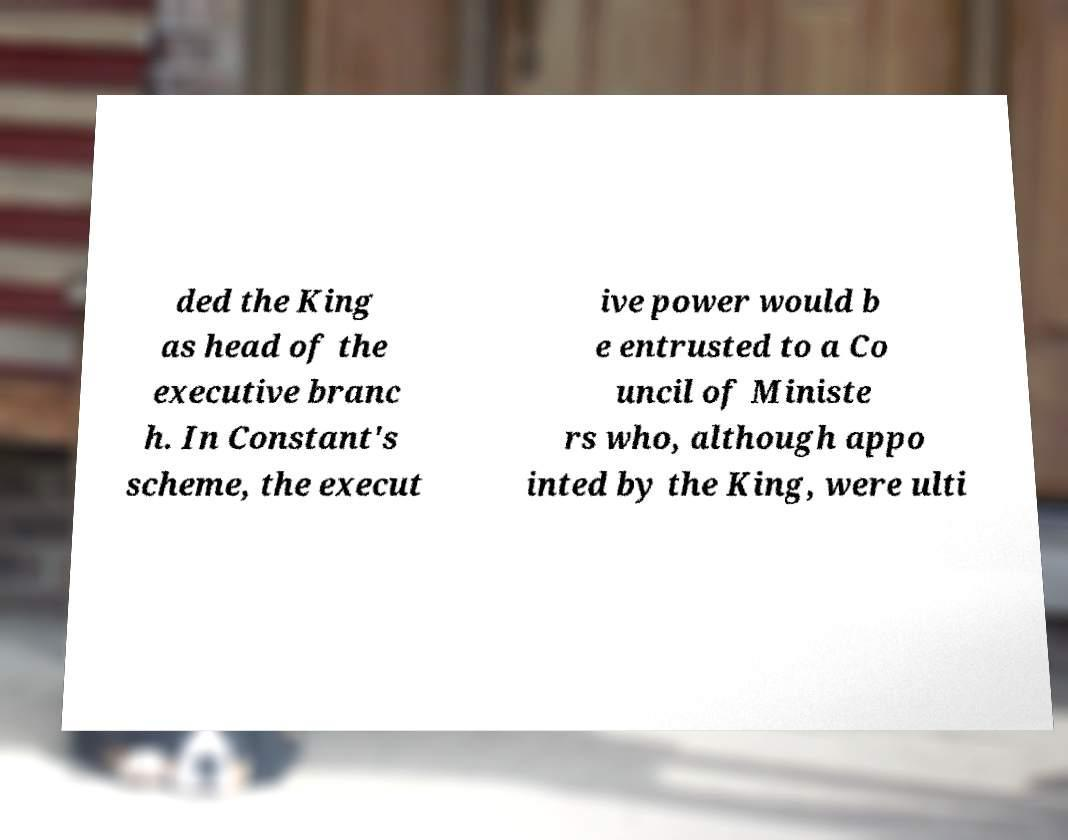Can you read and provide the text displayed in the image?This photo seems to have some interesting text. Can you extract and type it out for me? ded the King as head of the executive branc h. In Constant's scheme, the execut ive power would b e entrusted to a Co uncil of Ministe rs who, although appo inted by the King, were ulti 